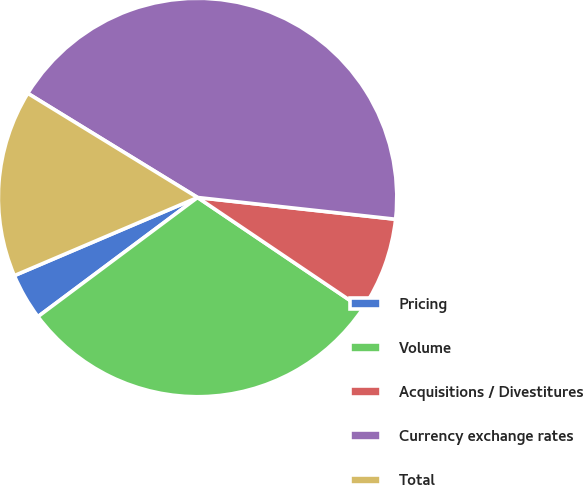Convert chart to OTSL. <chart><loc_0><loc_0><loc_500><loc_500><pie_chart><fcel>Pricing<fcel>Volume<fcel>Acquisitions / Divestitures<fcel>Currency exchange rates<fcel>Total<nl><fcel>3.79%<fcel>30.34%<fcel>7.71%<fcel>42.98%<fcel>15.17%<nl></chart> 